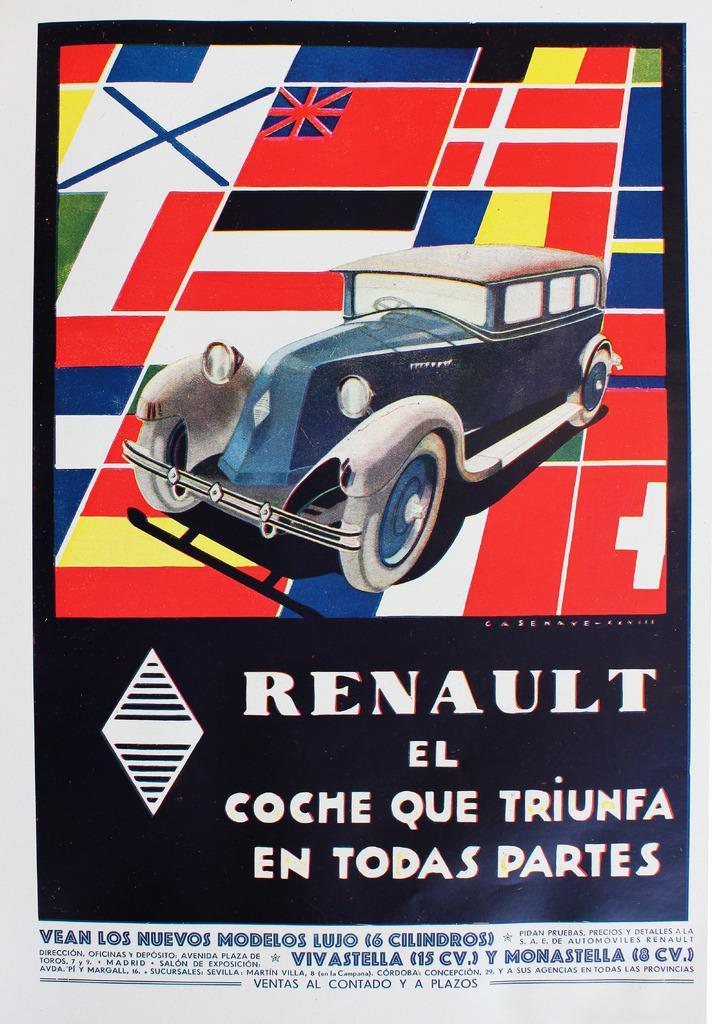Please provide a concise description of this image. In this image, we can see a poster, on that poster we can see a car, RENAULT is printed on the poster. 